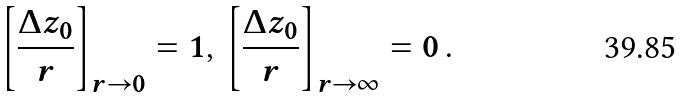<formula> <loc_0><loc_0><loc_500><loc_500>\left [ \frac { \Delta z _ { 0 } } { r } \right ] _ { r \rightarrow 0 } = 1 , \, \left [ \frac { \Delta z _ { 0 } } { r } \right ] _ { r \rightarrow \infty } = 0 \, .</formula> 